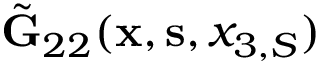Convert formula to latex. <formula><loc_0><loc_0><loc_500><loc_500>\tilde { G } _ { 2 2 } ( { x } , { s } , x _ { 3 , S } )</formula> 